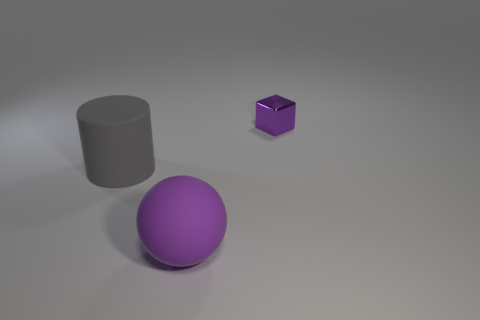Are there any other things that have the same material as the purple cube?
Offer a very short reply. No. Is the size of the block right of the gray matte object the same as the big purple ball?
Your response must be concise. No. What shape is the object that is behind the large ball and to the left of the small object?
Give a very brief answer. Cylinder. There is a purple matte thing; are there any matte objects behind it?
Provide a short and direct response. Yes. Are there any other things that have the same shape as the big purple object?
Offer a terse response. No. Is the shape of the gray matte object the same as the purple matte thing?
Provide a short and direct response. No. Is the number of gray matte objects that are behind the large gray cylinder the same as the number of metallic objects that are in front of the small shiny thing?
Your answer should be compact. Yes. How many other objects are the same material as the tiny object?
Your answer should be compact. 0. How many large things are metallic blocks or cyan metallic spheres?
Give a very brief answer. 0. Is the number of tiny metal blocks that are right of the small purple block the same as the number of blue matte cylinders?
Your response must be concise. Yes. 